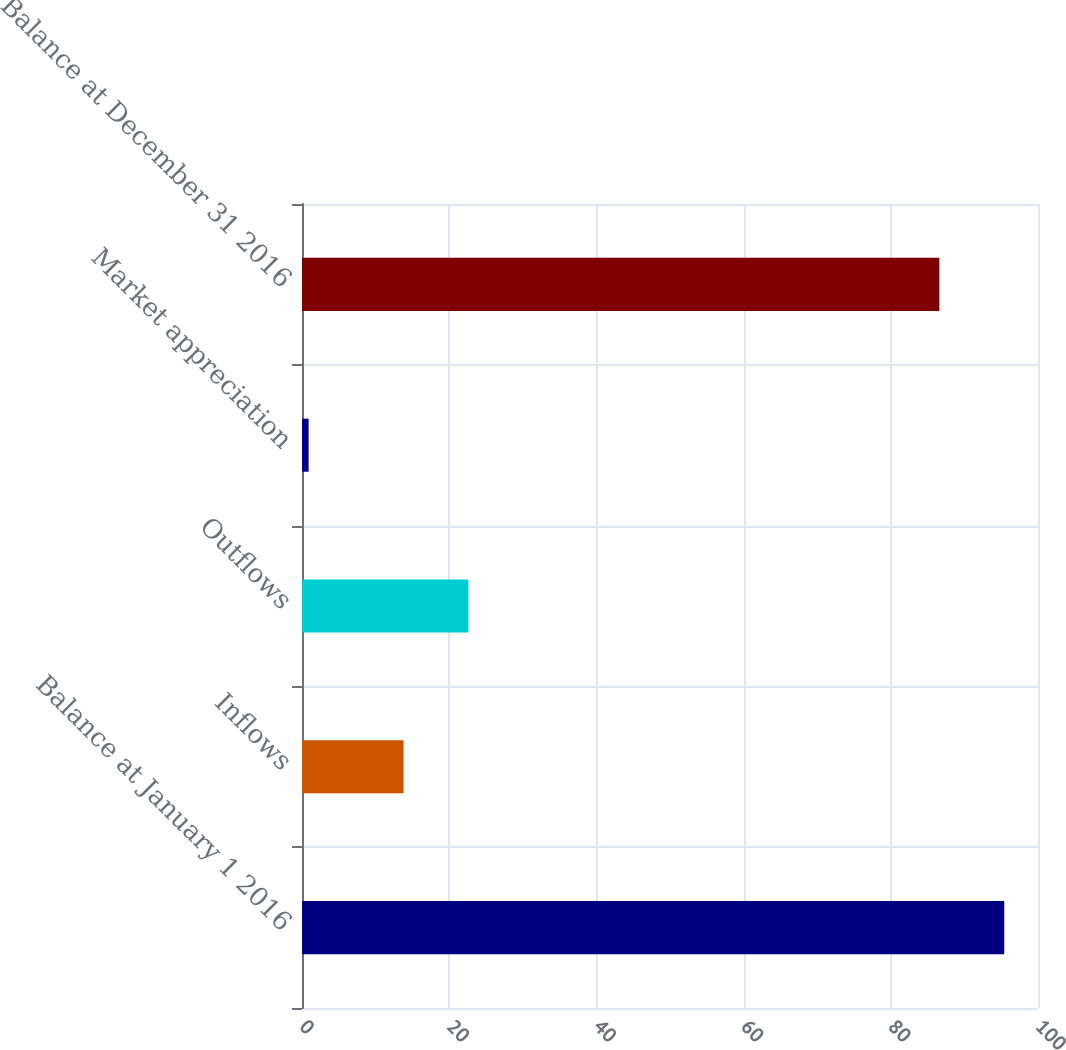<chart> <loc_0><loc_0><loc_500><loc_500><bar_chart><fcel>Balance at January 1 2016<fcel>Inflows<fcel>Outflows<fcel>Market appreciation<fcel>Balance at December 31 2016<nl><fcel>95.41<fcel>13.8<fcel>22.61<fcel>0.9<fcel>86.6<nl></chart> 